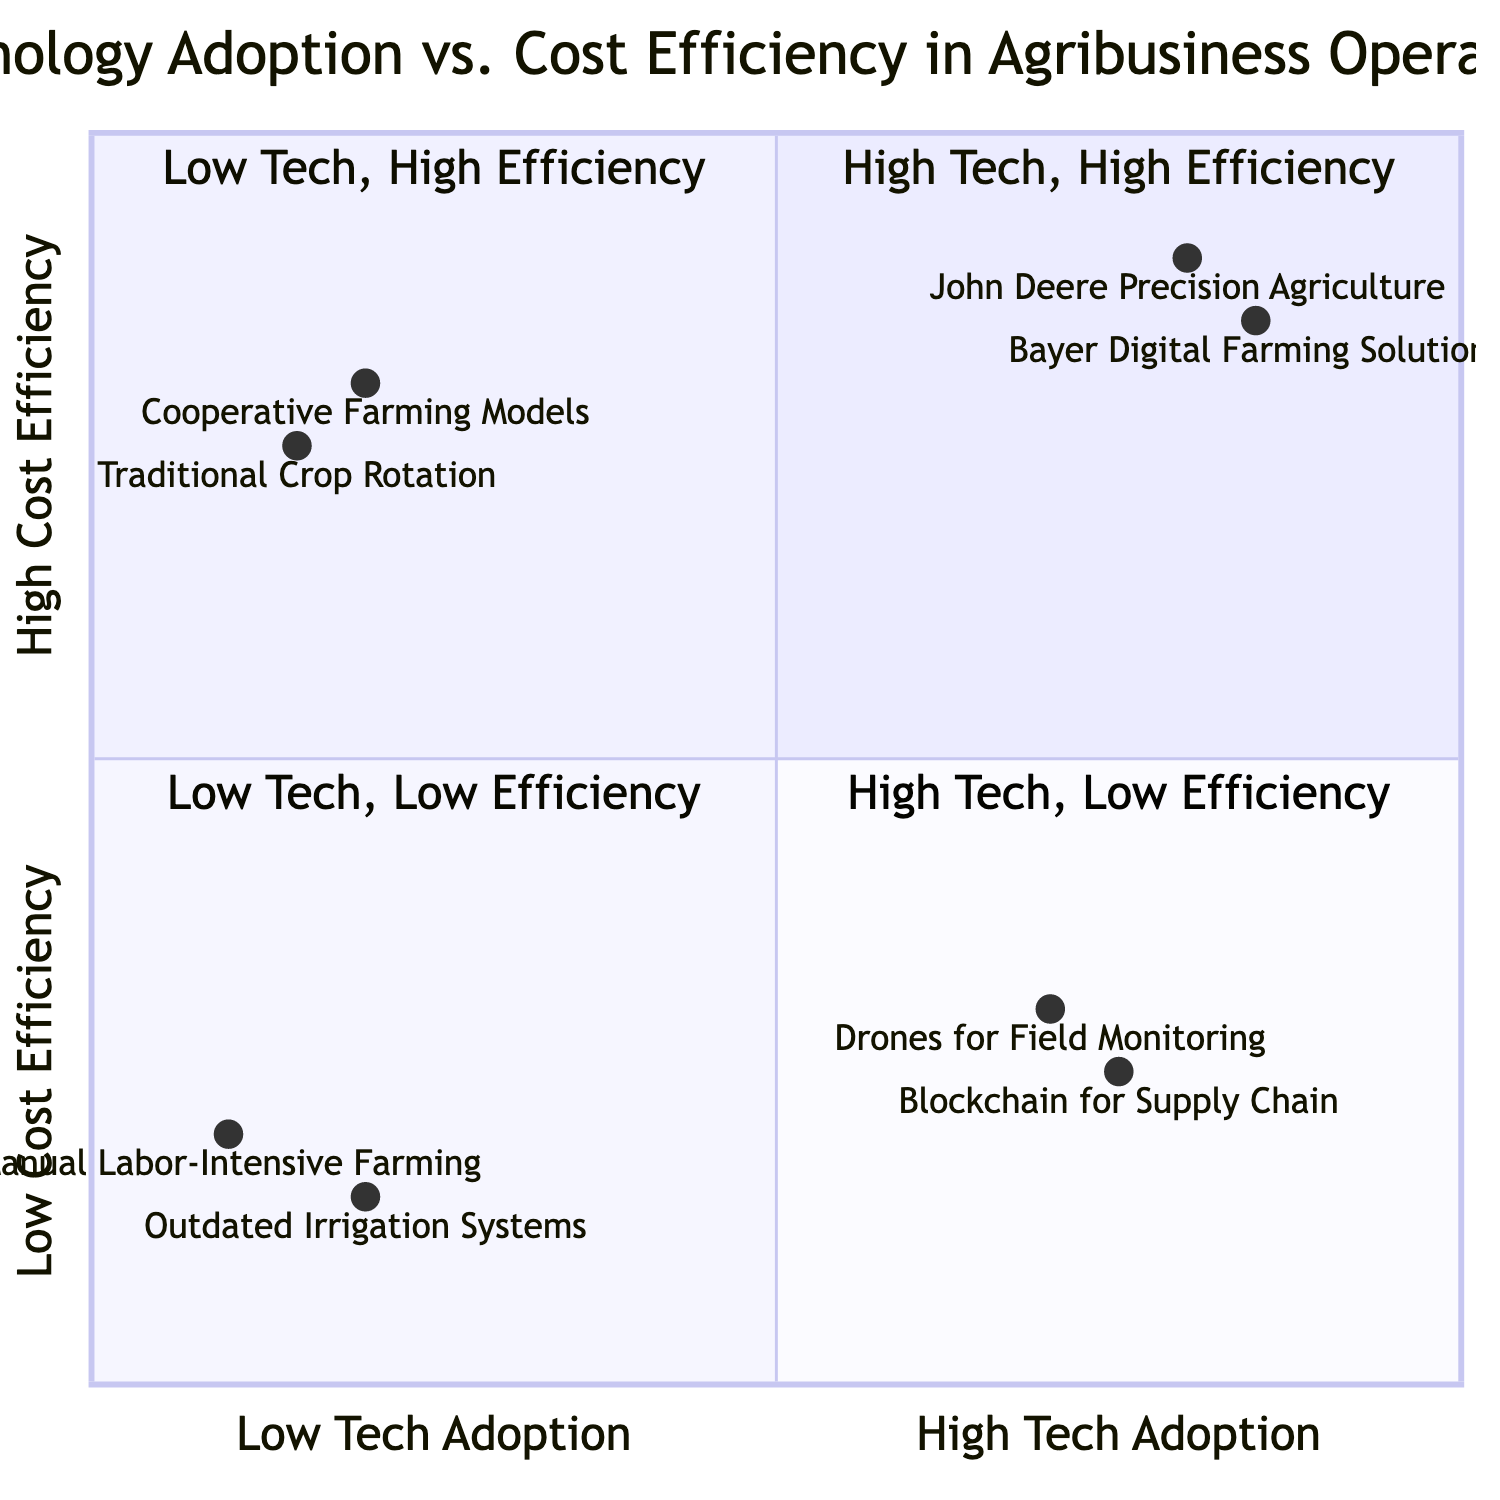What entities are located in the High Tech, High Efficiency quadrant? This quadrant contains entities that have high levels of technology adoption and high cost efficiency. According to the data, the entities listed in this quadrant are "John Deere Precision Agriculture" and "Bayer Digital Farming Solutions."
Answer: John Deere Precision Agriculture, Bayer Digital Farming Solutions How many entities are in the Low Tech, Low Efficiency quadrant? By reviewing the data, the Low Tech, Low Efficiency quadrant includes two entities: "Manual Labor-Intensive Farming" and "Outdated Irrigation Systems." Therefore, the count is two.
Answer: 2 Which entity has the highest technology adoption in the Low Tech, High Efficiency quadrant? The Low Tech, High Efficiency quadrant lists "Cooperative Farming Models" and "Traditional Crop Rotation." Their technology adoption scores, ranked from highest to lowest, show that "Traditional Crop Rotation" has a slightly higher adoption score of 0.15 compared to the 0.2 of "Cooperative Farming Models." Thus, the higher score means "Cooperative Farming Models" has the highest adoption in this quadrant.
Answer: Cooperative Farming Models What is the cost efficiency score of Drones for Field Monitoring? The data specifically provides a score for Drones for Field Monitoring, which is located in the Low Tech, Low Efficiency quadrant. The score is 0.3 for cost efficiency.
Answer: 0.3 Which quadrant contains the entity with the lowest cost efficiency? The quadrant with the lowest cost efficiency is the Low Tech, Low Efficiency quadrant, which includes "Manual Labor-Intensive Farming" and "Outdated Irrigation Systems." Both entities have relatively low efficiency scores, but "Outdated Irrigation Systems" has the lowest score of 0.15. Thus, the answer is the Low Tech, Low Efficiency quadrant.
Answer: Low Tech, Low Efficiency What is the relationship between technology adoption and cost efficiency for the entity Blockchain for Supply Chain? The entity "Blockchain for Supply Chain" is categorized under Low Tech, Low Efficiency, which indicates that it has high technology adoption but low cost efficiency. This demonstrates a lack of practical benefits in terms of cost savings despite high-tech implementation.
Answer: High adoption, low efficiency Which quadrant has entities that utilize traditional farming methods? The Low Tech, High Efficiency quadrant includes entities such as "Cooperative Farming Models" and "Traditional Crop Rotation." These entities are characterized by their reliance on traditional methods rather than modern technology.
Answer: Low Tech, High Efficiency 